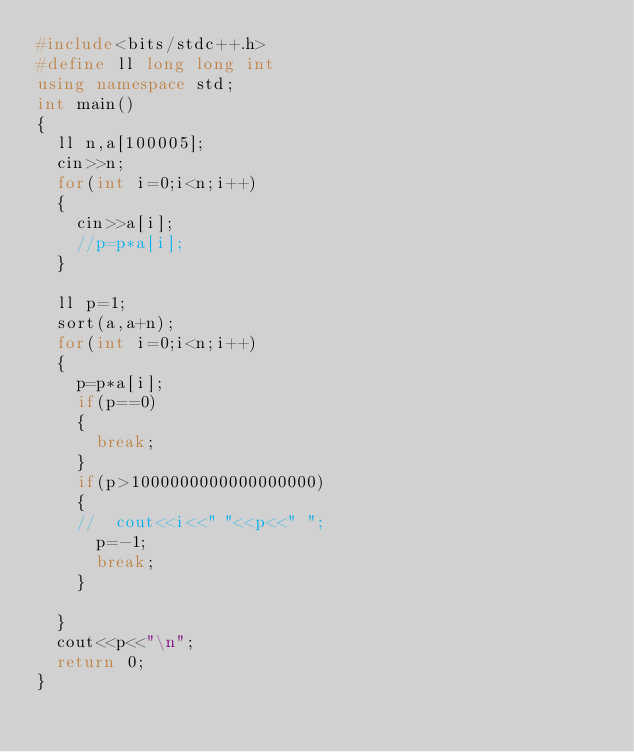Convert code to text. <code><loc_0><loc_0><loc_500><loc_500><_C++_>#include<bits/stdc++.h>
#define ll long long int
using namespace std;
int main()
{
  ll n,a[100005];
  cin>>n;
  for(int i=0;i<n;i++)
  {
    cin>>a[i];
    //p=p*a[i];
  }
  
  ll p=1;
  sort(a,a+n);
  for(int i=0;i<n;i++)
  {
    p=p*a[i];
    if(p==0)
    {
      break;
    }
    if(p>1000000000000000000)
    {
    //	cout<<i<<" "<<p<<" ";
      p=-1;
      break;
    }
    
  } 
  cout<<p<<"\n";
  return 0;
}
</code> 